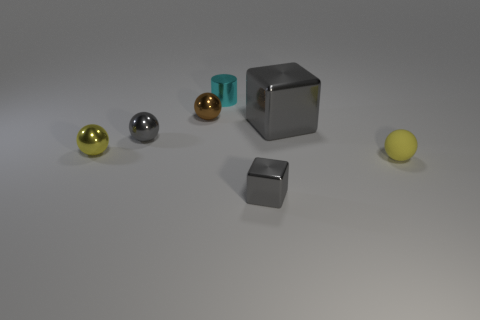Add 2 big gray cylinders. How many objects exist? 9 Subtract all blocks. How many objects are left? 5 Add 2 yellow metallic balls. How many yellow metallic balls are left? 3 Add 6 gray spheres. How many gray spheres exist? 7 Subtract 0 blue cylinders. How many objects are left? 7 Subtract all gray objects. Subtract all gray metal cubes. How many objects are left? 2 